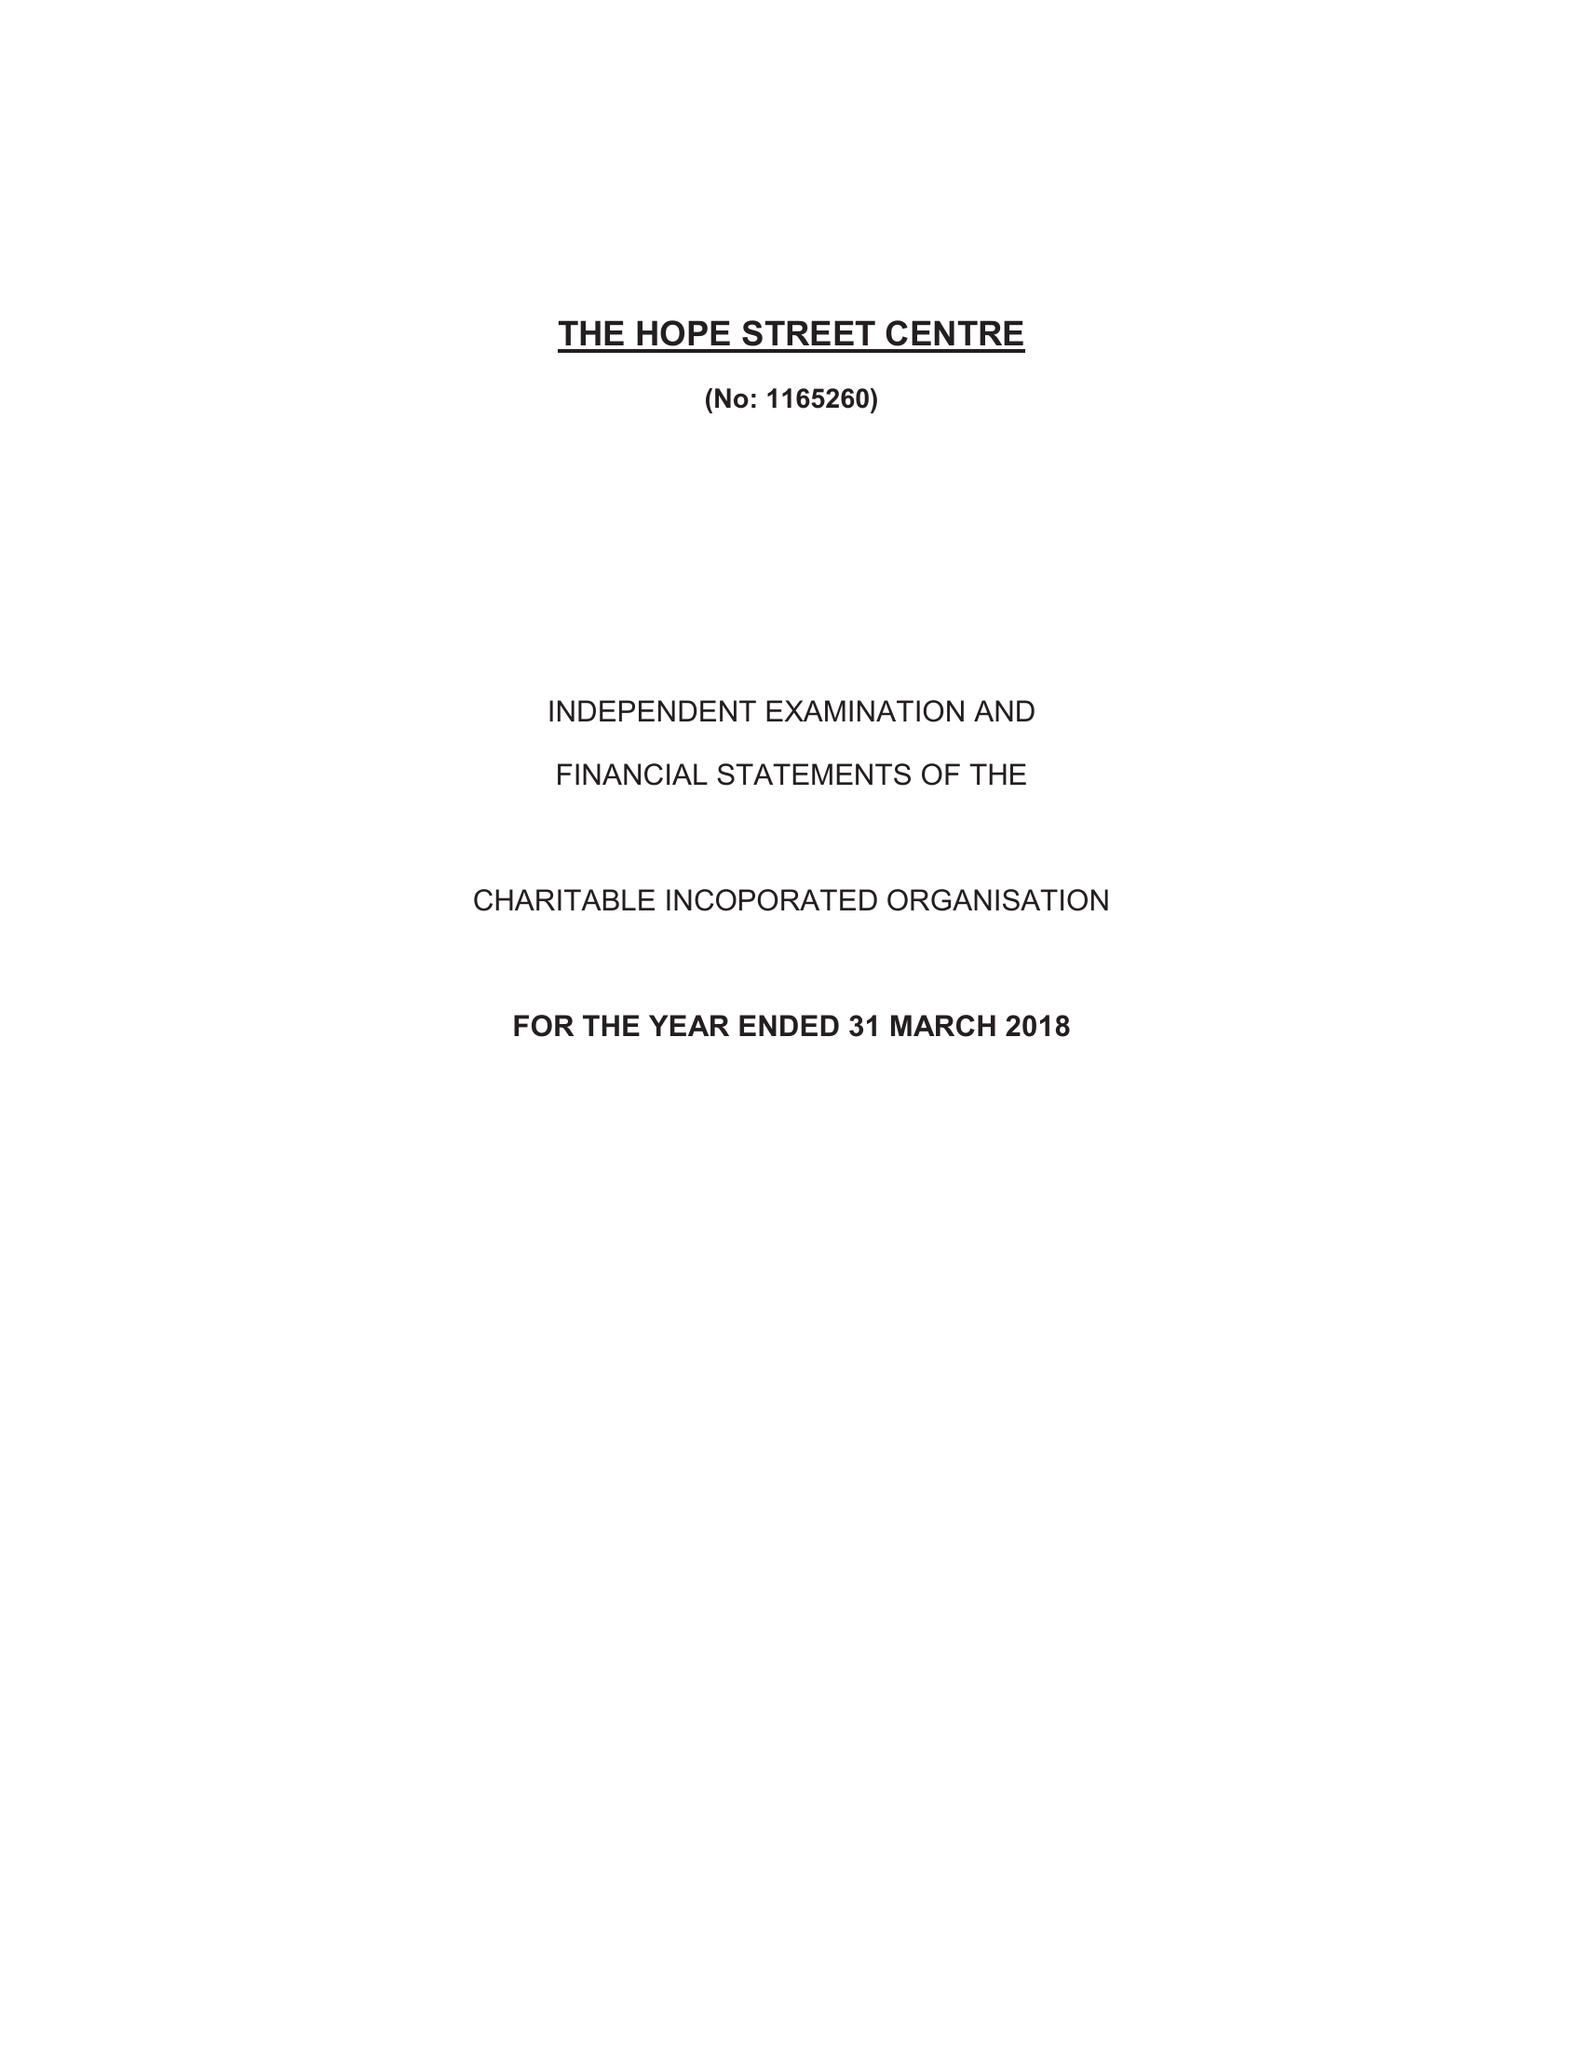What is the value for the report_date?
Answer the question using a single word or phrase. 2018-03-31 